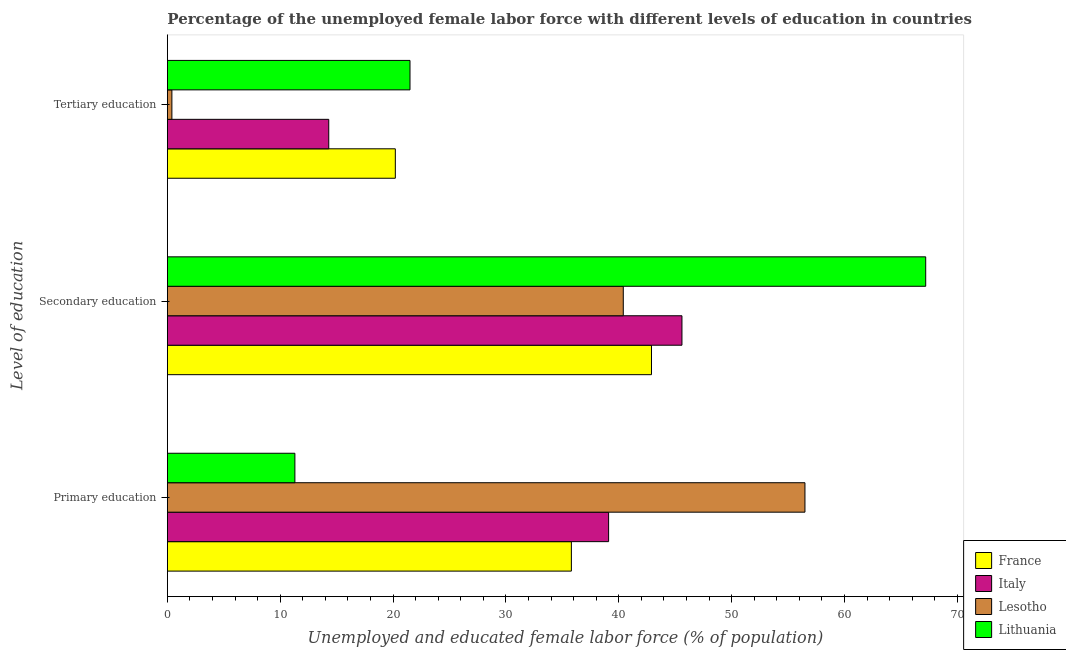How many different coloured bars are there?
Your response must be concise. 4. Are the number of bars on each tick of the Y-axis equal?
Make the answer very short. Yes. How many bars are there on the 2nd tick from the bottom?
Ensure brevity in your answer.  4. What is the label of the 1st group of bars from the top?
Your response must be concise. Tertiary education. What is the percentage of female labor force who received secondary education in Lesotho?
Give a very brief answer. 40.4. Across all countries, what is the minimum percentage of female labor force who received secondary education?
Make the answer very short. 40.4. In which country was the percentage of female labor force who received secondary education maximum?
Your answer should be very brief. Lithuania. In which country was the percentage of female labor force who received primary education minimum?
Provide a succinct answer. Lithuania. What is the total percentage of female labor force who received tertiary education in the graph?
Ensure brevity in your answer.  56.4. What is the difference between the percentage of female labor force who received primary education in Italy and that in Lithuania?
Your answer should be compact. 27.8. What is the difference between the percentage of female labor force who received tertiary education in France and the percentage of female labor force who received secondary education in Italy?
Your answer should be compact. -25.4. What is the average percentage of female labor force who received secondary education per country?
Your answer should be compact. 49.02. What is the difference between the percentage of female labor force who received secondary education and percentage of female labor force who received primary education in Lesotho?
Your answer should be very brief. -16.1. What is the ratio of the percentage of female labor force who received primary education in Lesotho to that in Italy?
Your answer should be compact. 1.45. Is the percentage of female labor force who received primary education in France less than that in Lithuania?
Make the answer very short. No. Is the difference between the percentage of female labor force who received secondary education in France and Italy greater than the difference between the percentage of female labor force who received primary education in France and Italy?
Offer a terse response. Yes. What is the difference between the highest and the second highest percentage of female labor force who received primary education?
Your answer should be very brief. 17.4. What is the difference between the highest and the lowest percentage of female labor force who received tertiary education?
Provide a succinct answer. 21.1. In how many countries, is the percentage of female labor force who received tertiary education greater than the average percentage of female labor force who received tertiary education taken over all countries?
Make the answer very short. 3. What does the 4th bar from the top in Primary education represents?
Give a very brief answer. France. What does the 4th bar from the bottom in Primary education represents?
Offer a terse response. Lithuania. How many bars are there?
Provide a succinct answer. 12. Are all the bars in the graph horizontal?
Give a very brief answer. Yes. How many countries are there in the graph?
Offer a very short reply. 4. Are the values on the major ticks of X-axis written in scientific E-notation?
Give a very brief answer. No. Does the graph contain any zero values?
Offer a terse response. No. Does the graph contain grids?
Ensure brevity in your answer.  No. What is the title of the graph?
Make the answer very short. Percentage of the unemployed female labor force with different levels of education in countries. What is the label or title of the X-axis?
Make the answer very short. Unemployed and educated female labor force (% of population). What is the label or title of the Y-axis?
Provide a succinct answer. Level of education. What is the Unemployed and educated female labor force (% of population) in France in Primary education?
Provide a short and direct response. 35.8. What is the Unemployed and educated female labor force (% of population) of Italy in Primary education?
Provide a succinct answer. 39.1. What is the Unemployed and educated female labor force (% of population) in Lesotho in Primary education?
Keep it short and to the point. 56.5. What is the Unemployed and educated female labor force (% of population) in Lithuania in Primary education?
Provide a short and direct response. 11.3. What is the Unemployed and educated female labor force (% of population) in France in Secondary education?
Provide a short and direct response. 42.9. What is the Unemployed and educated female labor force (% of population) in Italy in Secondary education?
Your answer should be compact. 45.6. What is the Unemployed and educated female labor force (% of population) of Lesotho in Secondary education?
Your answer should be compact. 40.4. What is the Unemployed and educated female labor force (% of population) of Lithuania in Secondary education?
Give a very brief answer. 67.2. What is the Unemployed and educated female labor force (% of population) in France in Tertiary education?
Provide a short and direct response. 20.2. What is the Unemployed and educated female labor force (% of population) in Italy in Tertiary education?
Make the answer very short. 14.3. What is the Unemployed and educated female labor force (% of population) in Lesotho in Tertiary education?
Your response must be concise. 0.4. What is the Unemployed and educated female labor force (% of population) in Lithuania in Tertiary education?
Ensure brevity in your answer.  21.5. Across all Level of education, what is the maximum Unemployed and educated female labor force (% of population) of France?
Provide a succinct answer. 42.9. Across all Level of education, what is the maximum Unemployed and educated female labor force (% of population) of Italy?
Provide a short and direct response. 45.6. Across all Level of education, what is the maximum Unemployed and educated female labor force (% of population) in Lesotho?
Your answer should be very brief. 56.5. Across all Level of education, what is the maximum Unemployed and educated female labor force (% of population) in Lithuania?
Your answer should be compact. 67.2. Across all Level of education, what is the minimum Unemployed and educated female labor force (% of population) of France?
Provide a succinct answer. 20.2. Across all Level of education, what is the minimum Unemployed and educated female labor force (% of population) in Italy?
Offer a terse response. 14.3. Across all Level of education, what is the minimum Unemployed and educated female labor force (% of population) in Lesotho?
Make the answer very short. 0.4. Across all Level of education, what is the minimum Unemployed and educated female labor force (% of population) of Lithuania?
Offer a very short reply. 11.3. What is the total Unemployed and educated female labor force (% of population) of France in the graph?
Give a very brief answer. 98.9. What is the total Unemployed and educated female labor force (% of population) in Italy in the graph?
Provide a short and direct response. 99. What is the total Unemployed and educated female labor force (% of population) in Lesotho in the graph?
Your answer should be compact. 97.3. What is the total Unemployed and educated female labor force (% of population) of Lithuania in the graph?
Offer a terse response. 100. What is the difference between the Unemployed and educated female labor force (% of population) of Lithuania in Primary education and that in Secondary education?
Your response must be concise. -55.9. What is the difference between the Unemployed and educated female labor force (% of population) of Italy in Primary education and that in Tertiary education?
Offer a terse response. 24.8. What is the difference between the Unemployed and educated female labor force (% of population) of Lesotho in Primary education and that in Tertiary education?
Your response must be concise. 56.1. What is the difference between the Unemployed and educated female labor force (% of population) in Lithuania in Primary education and that in Tertiary education?
Ensure brevity in your answer.  -10.2. What is the difference between the Unemployed and educated female labor force (% of population) in France in Secondary education and that in Tertiary education?
Provide a succinct answer. 22.7. What is the difference between the Unemployed and educated female labor force (% of population) of Italy in Secondary education and that in Tertiary education?
Your answer should be compact. 31.3. What is the difference between the Unemployed and educated female labor force (% of population) in Lithuania in Secondary education and that in Tertiary education?
Make the answer very short. 45.7. What is the difference between the Unemployed and educated female labor force (% of population) of France in Primary education and the Unemployed and educated female labor force (% of population) of Italy in Secondary education?
Give a very brief answer. -9.8. What is the difference between the Unemployed and educated female labor force (% of population) of France in Primary education and the Unemployed and educated female labor force (% of population) of Lesotho in Secondary education?
Your answer should be very brief. -4.6. What is the difference between the Unemployed and educated female labor force (% of population) in France in Primary education and the Unemployed and educated female labor force (% of population) in Lithuania in Secondary education?
Keep it short and to the point. -31.4. What is the difference between the Unemployed and educated female labor force (% of population) in Italy in Primary education and the Unemployed and educated female labor force (% of population) in Lithuania in Secondary education?
Your answer should be very brief. -28.1. What is the difference between the Unemployed and educated female labor force (% of population) of France in Primary education and the Unemployed and educated female labor force (% of population) of Lesotho in Tertiary education?
Give a very brief answer. 35.4. What is the difference between the Unemployed and educated female labor force (% of population) in France in Primary education and the Unemployed and educated female labor force (% of population) in Lithuania in Tertiary education?
Your answer should be compact. 14.3. What is the difference between the Unemployed and educated female labor force (% of population) in Italy in Primary education and the Unemployed and educated female labor force (% of population) in Lesotho in Tertiary education?
Provide a short and direct response. 38.7. What is the difference between the Unemployed and educated female labor force (% of population) of Italy in Primary education and the Unemployed and educated female labor force (% of population) of Lithuania in Tertiary education?
Make the answer very short. 17.6. What is the difference between the Unemployed and educated female labor force (% of population) in France in Secondary education and the Unemployed and educated female labor force (% of population) in Italy in Tertiary education?
Make the answer very short. 28.6. What is the difference between the Unemployed and educated female labor force (% of population) in France in Secondary education and the Unemployed and educated female labor force (% of population) in Lesotho in Tertiary education?
Your response must be concise. 42.5. What is the difference between the Unemployed and educated female labor force (% of population) in France in Secondary education and the Unemployed and educated female labor force (% of population) in Lithuania in Tertiary education?
Keep it short and to the point. 21.4. What is the difference between the Unemployed and educated female labor force (% of population) of Italy in Secondary education and the Unemployed and educated female labor force (% of population) of Lesotho in Tertiary education?
Offer a terse response. 45.2. What is the difference between the Unemployed and educated female labor force (% of population) in Italy in Secondary education and the Unemployed and educated female labor force (% of population) in Lithuania in Tertiary education?
Make the answer very short. 24.1. What is the difference between the Unemployed and educated female labor force (% of population) in Lesotho in Secondary education and the Unemployed and educated female labor force (% of population) in Lithuania in Tertiary education?
Your answer should be very brief. 18.9. What is the average Unemployed and educated female labor force (% of population) of France per Level of education?
Keep it short and to the point. 32.97. What is the average Unemployed and educated female labor force (% of population) in Lesotho per Level of education?
Keep it short and to the point. 32.43. What is the average Unemployed and educated female labor force (% of population) in Lithuania per Level of education?
Offer a terse response. 33.33. What is the difference between the Unemployed and educated female labor force (% of population) in France and Unemployed and educated female labor force (% of population) in Lesotho in Primary education?
Offer a terse response. -20.7. What is the difference between the Unemployed and educated female labor force (% of population) of France and Unemployed and educated female labor force (% of population) of Lithuania in Primary education?
Your answer should be compact. 24.5. What is the difference between the Unemployed and educated female labor force (% of population) in Italy and Unemployed and educated female labor force (% of population) in Lesotho in Primary education?
Offer a very short reply. -17.4. What is the difference between the Unemployed and educated female labor force (% of population) in Italy and Unemployed and educated female labor force (% of population) in Lithuania in Primary education?
Provide a short and direct response. 27.8. What is the difference between the Unemployed and educated female labor force (% of population) of Lesotho and Unemployed and educated female labor force (% of population) of Lithuania in Primary education?
Give a very brief answer. 45.2. What is the difference between the Unemployed and educated female labor force (% of population) of France and Unemployed and educated female labor force (% of population) of Italy in Secondary education?
Your answer should be very brief. -2.7. What is the difference between the Unemployed and educated female labor force (% of population) in France and Unemployed and educated female labor force (% of population) in Lithuania in Secondary education?
Make the answer very short. -24.3. What is the difference between the Unemployed and educated female labor force (% of population) of Italy and Unemployed and educated female labor force (% of population) of Lithuania in Secondary education?
Your answer should be very brief. -21.6. What is the difference between the Unemployed and educated female labor force (% of population) of Lesotho and Unemployed and educated female labor force (% of population) of Lithuania in Secondary education?
Keep it short and to the point. -26.8. What is the difference between the Unemployed and educated female labor force (% of population) in France and Unemployed and educated female labor force (% of population) in Lesotho in Tertiary education?
Your answer should be compact. 19.8. What is the difference between the Unemployed and educated female labor force (% of population) in France and Unemployed and educated female labor force (% of population) in Lithuania in Tertiary education?
Keep it short and to the point. -1.3. What is the difference between the Unemployed and educated female labor force (% of population) of Italy and Unemployed and educated female labor force (% of population) of Lesotho in Tertiary education?
Your response must be concise. 13.9. What is the difference between the Unemployed and educated female labor force (% of population) in Italy and Unemployed and educated female labor force (% of population) in Lithuania in Tertiary education?
Give a very brief answer. -7.2. What is the difference between the Unemployed and educated female labor force (% of population) in Lesotho and Unemployed and educated female labor force (% of population) in Lithuania in Tertiary education?
Make the answer very short. -21.1. What is the ratio of the Unemployed and educated female labor force (% of population) in France in Primary education to that in Secondary education?
Your answer should be compact. 0.83. What is the ratio of the Unemployed and educated female labor force (% of population) of Italy in Primary education to that in Secondary education?
Ensure brevity in your answer.  0.86. What is the ratio of the Unemployed and educated female labor force (% of population) of Lesotho in Primary education to that in Secondary education?
Offer a very short reply. 1.4. What is the ratio of the Unemployed and educated female labor force (% of population) of Lithuania in Primary education to that in Secondary education?
Keep it short and to the point. 0.17. What is the ratio of the Unemployed and educated female labor force (% of population) in France in Primary education to that in Tertiary education?
Provide a succinct answer. 1.77. What is the ratio of the Unemployed and educated female labor force (% of population) of Italy in Primary education to that in Tertiary education?
Your answer should be compact. 2.73. What is the ratio of the Unemployed and educated female labor force (% of population) of Lesotho in Primary education to that in Tertiary education?
Ensure brevity in your answer.  141.25. What is the ratio of the Unemployed and educated female labor force (% of population) in Lithuania in Primary education to that in Tertiary education?
Offer a terse response. 0.53. What is the ratio of the Unemployed and educated female labor force (% of population) of France in Secondary education to that in Tertiary education?
Ensure brevity in your answer.  2.12. What is the ratio of the Unemployed and educated female labor force (% of population) in Italy in Secondary education to that in Tertiary education?
Your answer should be very brief. 3.19. What is the ratio of the Unemployed and educated female labor force (% of population) in Lesotho in Secondary education to that in Tertiary education?
Offer a terse response. 101. What is the ratio of the Unemployed and educated female labor force (% of population) in Lithuania in Secondary education to that in Tertiary education?
Ensure brevity in your answer.  3.13. What is the difference between the highest and the second highest Unemployed and educated female labor force (% of population) of Lithuania?
Give a very brief answer. 45.7. What is the difference between the highest and the lowest Unemployed and educated female labor force (% of population) in France?
Your answer should be very brief. 22.7. What is the difference between the highest and the lowest Unemployed and educated female labor force (% of population) of Italy?
Keep it short and to the point. 31.3. What is the difference between the highest and the lowest Unemployed and educated female labor force (% of population) in Lesotho?
Provide a succinct answer. 56.1. What is the difference between the highest and the lowest Unemployed and educated female labor force (% of population) of Lithuania?
Make the answer very short. 55.9. 